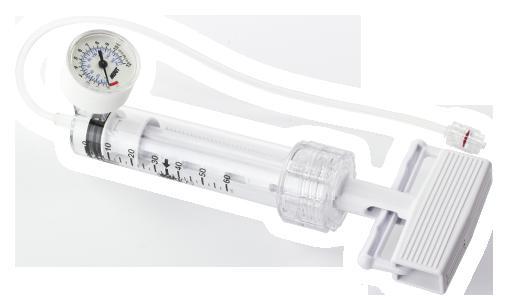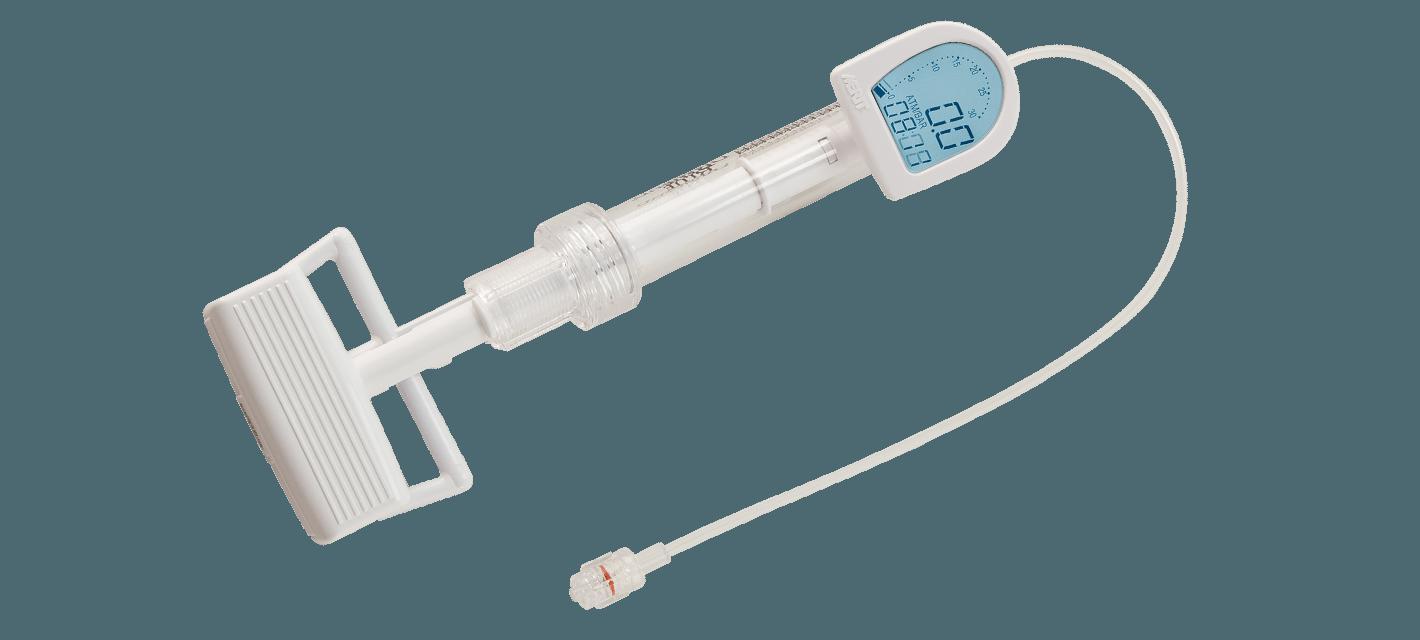The first image is the image on the left, the second image is the image on the right. Assess this claim about the two images: "At least 1 device has a red stripe above it.". Correct or not? Answer yes or no. No. 